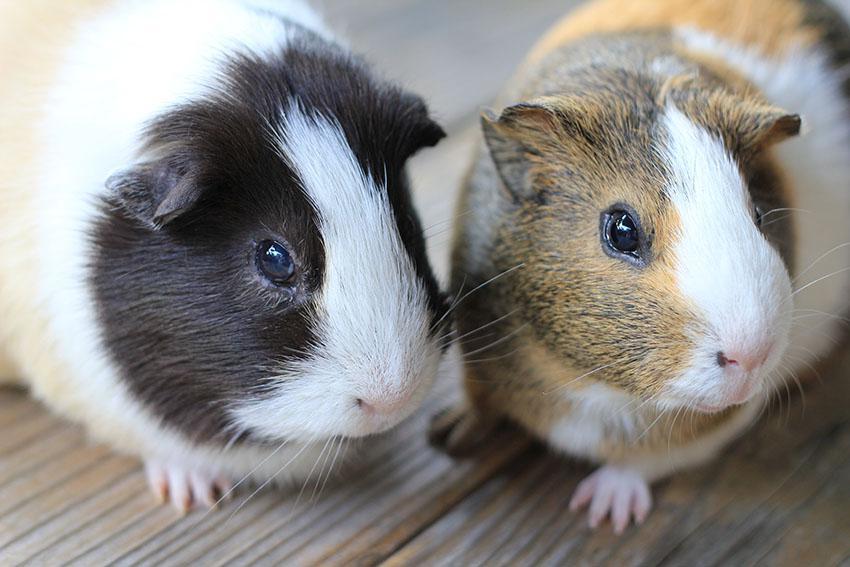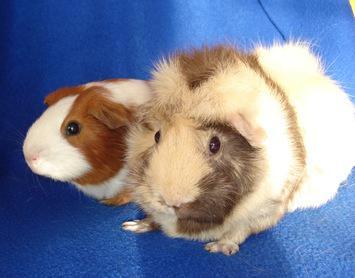The first image is the image on the left, the second image is the image on the right. Examine the images to the left and right. Is the description "There is at least one guinea pig eating a green food item" accurate? Answer yes or no. No. The first image is the image on the left, the second image is the image on the right. Considering the images on both sides, is "An image shows a pair of hamsters nibbling on something green." valid? Answer yes or no. No. 